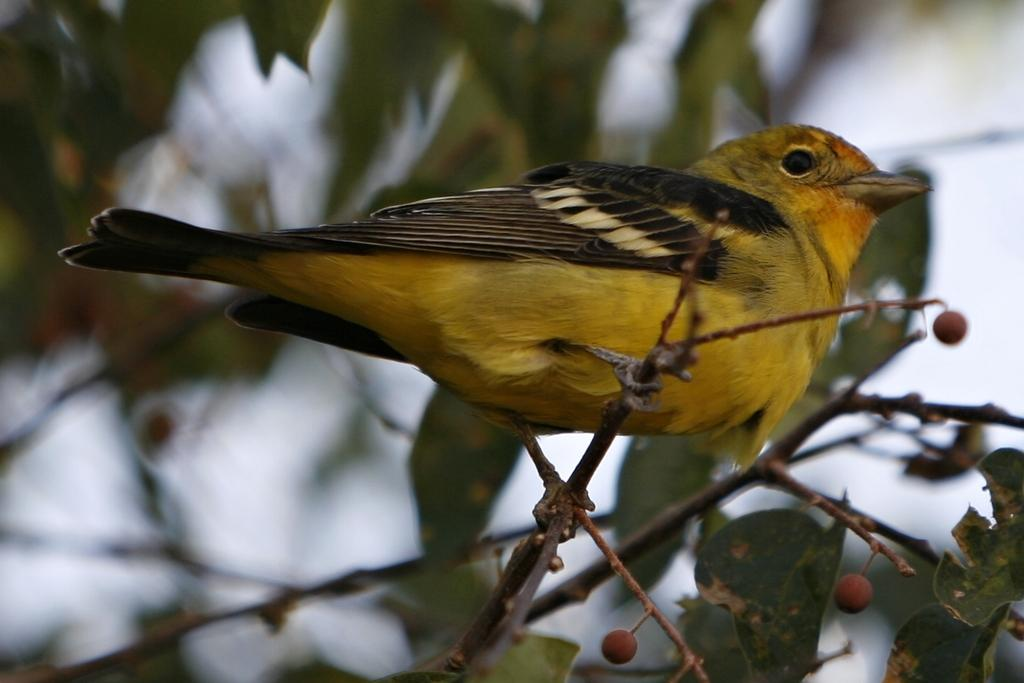What type of animal can be seen in the image? There is a bird in the image. Where is the bird located in the image? The bird is on the branch of a plant. What is special about the plant in the image? The plant has berries. Can you describe the background of the image? The background of the image is blurred, and leaves and objects are visible. What type of slope can be seen in the image? There is no slope present in the image; it features a bird on a plant with berries, and the background is blurred with leaves and objects visible. 